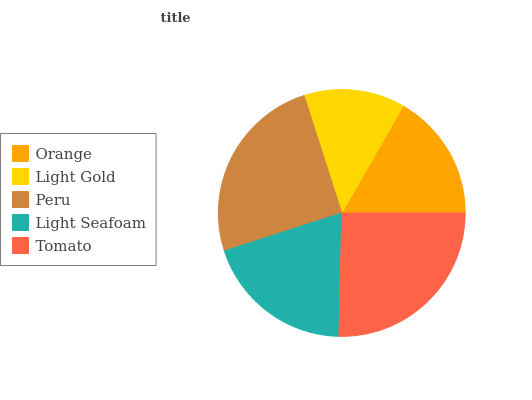Is Light Gold the minimum?
Answer yes or no. Yes. Is Tomato the maximum?
Answer yes or no. Yes. Is Peru the minimum?
Answer yes or no. No. Is Peru the maximum?
Answer yes or no. No. Is Peru greater than Light Gold?
Answer yes or no. Yes. Is Light Gold less than Peru?
Answer yes or no. Yes. Is Light Gold greater than Peru?
Answer yes or no. No. Is Peru less than Light Gold?
Answer yes or no. No. Is Light Seafoam the high median?
Answer yes or no. Yes. Is Light Seafoam the low median?
Answer yes or no. Yes. Is Peru the high median?
Answer yes or no. No. Is Tomato the low median?
Answer yes or no. No. 